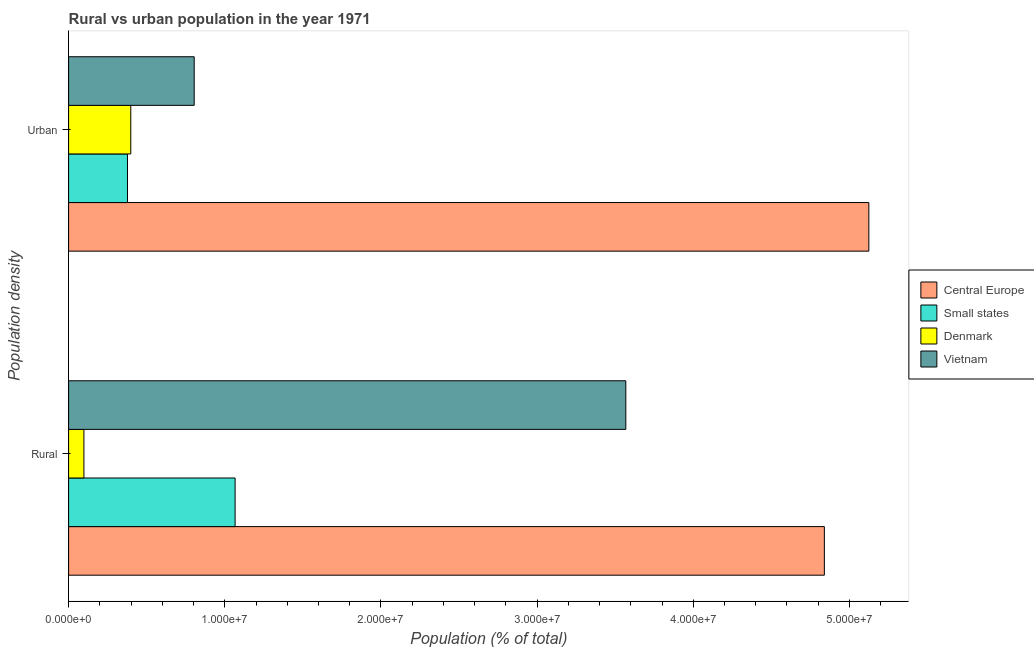How many different coloured bars are there?
Ensure brevity in your answer.  4. How many groups of bars are there?
Your response must be concise. 2. Are the number of bars on each tick of the Y-axis equal?
Provide a short and direct response. Yes. How many bars are there on the 2nd tick from the top?
Give a very brief answer. 4. How many bars are there on the 2nd tick from the bottom?
Provide a short and direct response. 4. What is the label of the 1st group of bars from the top?
Your answer should be very brief. Urban. What is the rural population density in Small states?
Make the answer very short. 1.07e+07. Across all countries, what is the maximum rural population density?
Offer a very short reply. 4.84e+07. Across all countries, what is the minimum urban population density?
Your response must be concise. 3.77e+06. In which country was the rural population density maximum?
Provide a short and direct response. Central Europe. In which country was the rural population density minimum?
Keep it short and to the point. Denmark. What is the total urban population density in the graph?
Provide a short and direct response. 6.70e+07. What is the difference between the urban population density in Vietnam and that in Small states?
Provide a succinct answer. 4.27e+06. What is the difference between the urban population density in Vietnam and the rural population density in Central Europe?
Provide a short and direct response. -4.04e+07. What is the average urban population density per country?
Offer a terse response. 1.68e+07. What is the difference between the urban population density and rural population density in Central Europe?
Make the answer very short. 2.85e+06. What is the ratio of the urban population density in Denmark to that in Central Europe?
Keep it short and to the point. 0.08. What does the 4th bar from the top in Urban represents?
Offer a very short reply. Central Europe. What does the 4th bar from the bottom in Urban represents?
Provide a succinct answer. Vietnam. How many bars are there?
Ensure brevity in your answer.  8. Are all the bars in the graph horizontal?
Provide a succinct answer. Yes. What is the difference between two consecutive major ticks on the X-axis?
Ensure brevity in your answer.  1.00e+07. Does the graph contain any zero values?
Your answer should be compact. No. Does the graph contain grids?
Your answer should be very brief. No. How many legend labels are there?
Make the answer very short. 4. What is the title of the graph?
Your answer should be very brief. Rural vs urban population in the year 1971. What is the label or title of the X-axis?
Your response must be concise. Population (% of total). What is the label or title of the Y-axis?
Ensure brevity in your answer.  Population density. What is the Population (% of total) in Central Europe in Rural?
Keep it short and to the point. 4.84e+07. What is the Population (% of total) in Small states in Rural?
Provide a short and direct response. 1.07e+07. What is the Population (% of total) in Denmark in Rural?
Your response must be concise. 9.81e+05. What is the Population (% of total) of Vietnam in Rural?
Offer a very short reply. 3.57e+07. What is the Population (% of total) in Central Europe in Urban?
Ensure brevity in your answer.  5.12e+07. What is the Population (% of total) in Small states in Urban?
Offer a very short reply. 3.77e+06. What is the Population (% of total) of Denmark in Urban?
Provide a succinct answer. 3.98e+06. What is the Population (% of total) in Vietnam in Urban?
Give a very brief answer. 8.04e+06. Across all Population density, what is the maximum Population (% of total) in Central Europe?
Your response must be concise. 5.12e+07. Across all Population density, what is the maximum Population (% of total) in Small states?
Your answer should be compact. 1.07e+07. Across all Population density, what is the maximum Population (% of total) of Denmark?
Offer a very short reply. 3.98e+06. Across all Population density, what is the maximum Population (% of total) in Vietnam?
Your answer should be very brief. 3.57e+07. Across all Population density, what is the minimum Population (% of total) of Central Europe?
Provide a succinct answer. 4.84e+07. Across all Population density, what is the minimum Population (% of total) in Small states?
Offer a very short reply. 3.77e+06. Across all Population density, what is the minimum Population (% of total) in Denmark?
Make the answer very short. 9.81e+05. Across all Population density, what is the minimum Population (% of total) in Vietnam?
Offer a terse response. 8.04e+06. What is the total Population (% of total) in Central Europe in the graph?
Offer a very short reply. 9.96e+07. What is the total Population (% of total) in Small states in the graph?
Your answer should be compact. 1.44e+07. What is the total Population (% of total) in Denmark in the graph?
Provide a succinct answer. 4.96e+06. What is the total Population (% of total) of Vietnam in the graph?
Provide a short and direct response. 4.37e+07. What is the difference between the Population (% of total) in Central Europe in Rural and that in Urban?
Your answer should be compact. -2.85e+06. What is the difference between the Population (% of total) in Small states in Rural and that in Urban?
Provide a succinct answer. 6.89e+06. What is the difference between the Population (% of total) of Denmark in Rural and that in Urban?
Offer a terse response. -3.00e+06. What is the difference between the Population (% of total) of Vietnam in Rural and that in Urban?
Keep it short and to the point. 2.76e+07. What is the difference between the Population (% of total) of Central Europe in Rural and the Population (% of total) of Small states in Urban?
Give a very brief answer. 4.46e+07. What is the difference between the Population (% of total) of Central Europe in Rural and the Population (% of total) of Denmark in Urban?
Provide a short and direct response. 4.44e+07. What is the difference between the Population (% of total) in Central Europe in Rural and the Population (% of total) in Vietnam in Urban?
Ensure brevity in your answer.  4.04e+07. What is the difference between the Population (% of total) in Small states in Rural and the Population (% of total) in Denmark in Urban?
Offer a terse response. 6.68e+06. What is the difference between the Population (% of total) in Small states in Rural and the Population (% of total) in Vietnam in Urban?
Your answer should be compact. 2.62e+06. What is the difference between the Population (% of total) in Denmark in Rural and the Population (% of total) in Vietnam in Urban?
Your response must be concise. -7.06e+06. What is the average Population (% of total) of Central Europe per Population density?
Provide a short and direct response. 4.98e+07. What is the average Population (% of total) in Small states per Population density?
Offer a very short reply. 7.22e+06. What is the average Population (% of total) of Denmark per Population density?
Give a very brief answer. 2.48e+06. What is the average Population (% of total) in Vietnam per Population density?
Make the answer very short. 2.19e+07. What is the difference between the Population (% of total) in Central Europe and Population (% of total) in Small states in Rural?
Offer a terse response. 3.77e+07. What is the difference between the Population (% of total) of Central Europe and Population (% of total) of Denmark in Rural?
Provide a succinct answer. 4.74e+07. What is the difference between the Population (% of total) in Central Europe and Population (% of total) in Vietnam in Rural?
Provide a succinct answer. 1.27e+07. What is the difference between the Population (% of total) in Small states and Population (% of total) in Denmark in Rural?
Your answer should be compact. 9.68e+06. What is the difference between the Population (% of total) in Small states and Population (% of total) in Vietnam in Rural?
Make the answer very short. -2.50e+07. What is the difference between the Population (% of total) of Denmark and Population (% of total) of Vietnam in Rural?
Keep it short and to the point. -3.47e+07. What is the difference between the Population (% of total) in Central Europe and Population (% of total) in Small states in Urban?
Your answer should be compact. 4.75e+07. What is the difference between the Population (% of total) in Central Europe and Population (% of total) in Denmark in Urban?
Make the answer very short. 4.73e+07. What is the difference between the Population (% of total) in Central Europe and Population (% of total) in Vietnam in Urban?
Provide a succinct answer. 4.32e+07. What is the difference between the Population (% of total) in Small states and Population (% of total) in Denmark in Urban?
Make the answer very short. -2.13e+05. What is the difference between the Population (% of total) in Small states and Population (% of total) in Vietnam in Urban?
Ensure brevity in your answer.  -4.27e+06. What is the difference between the Population (% of total) of Denmark and Population (% of total) of Vietnam in Urban?
Offer a terse response. -4.06e+06. What is the ratio of the Population (% of total) in Small states in Rural to that in Urban?
Your response must be concise. 2.83. What is the ratio of the Population (% of total) in Denmark in Rural to that in Urban?
Ensure brevity in your answer.  0.25. What is the ratio of the Population (% of total) in Vietnam in Rural to that in Urban?
Make the answer very short. 4.44. What is the difference between the highest and the second highest Population (% of total) in Central Europe?
Ensure brevity in your answer.  2.85e+06. What is the difference between the highest and the second highest Population (% of total) in Small states?
Provide a succinct answer. 6.89e+06. What is the difference between the highest and the second highest Population (% of total) of Denmark?
Offer a very short reply. 3.00e+06. What is the difference between the highest and the second highest Population (% of total) of Vietnam?
Make the answer very short. 2.76e+07. What is the difference between the highest and the lowest Population (% of total) in Central Europe?
Offer a terse response. 2.85e+06. What is the difference between the highest and the lowest Population (% of total) in Small states?
Provide a succinct answer. 6.89e+06. What is the difference between the highest and the lowest Population (% of total) in Denmark?
Your answer should be compact. 3.00e+06. What is the difference between the highest and the lowest Population (% of total) in Vietnam?
Provide a short and direct response. 2.76e+07. 